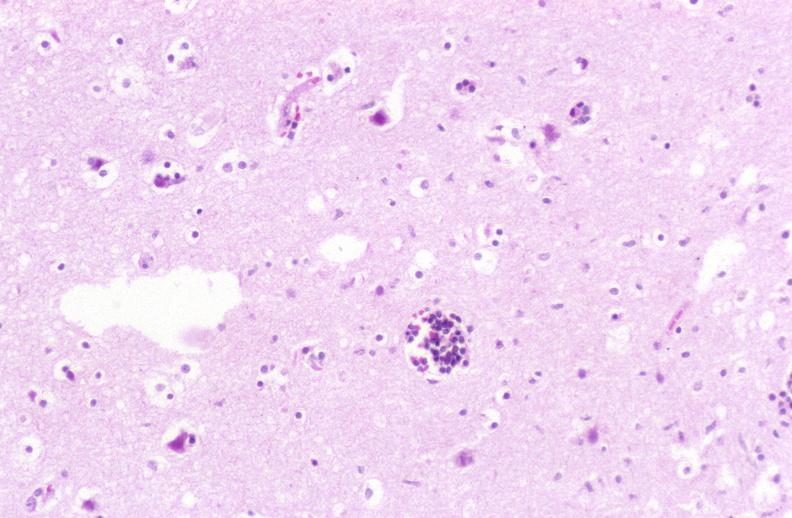what does this image show?
Answer the question using a single word or phrase. Brain 